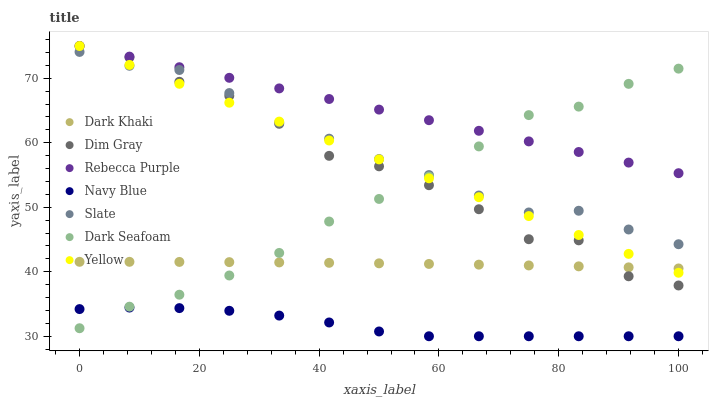Does Navy Blue have the minimum area under the curve?
Answer yes or no. Yes. Does Rebecca Purple have the maximum area under the curve?
Answer yes or no. Yes. Does Slate have the minimum area under the curve?
Answer yes or no. No. Does Slate have the maximum area under the curve?
Answer yes or no. No. Is Yellow the smoothest?
Answer yes or no. Yes. Is Dim Gray the roughest?
Answer yes or no. Yes. Is Navy Blue the smoothest?
Answer yes or no. No. Is Navy Blue the roughest?
Answer yes or no. No. Does Navy Blue have the lowest value?
Answer yes or no. Yes. Does Slate have the lowest value?
Answer yes or no. No. Does Rebecca Purple have the highest value?
Answer yes or no. Yes. Does Slate have the highest value?
Answer yes or no. No. Is Dark Khaki less than Slate?
Answer yes or no. Yes. Is Dim Gray greater than Navy Blue?
Answer yes or no. Yes. Does Dark Khaki intersect Yellow?
Answer yes or no. Yes. Is Dark Khaki less than Yellow?
Answer yes or no. No. Is Dark Khaki greater than Yellow?
Answer yes or no. No. Does Dark Khaki intersect Slate?
Answer yes or no. No. 